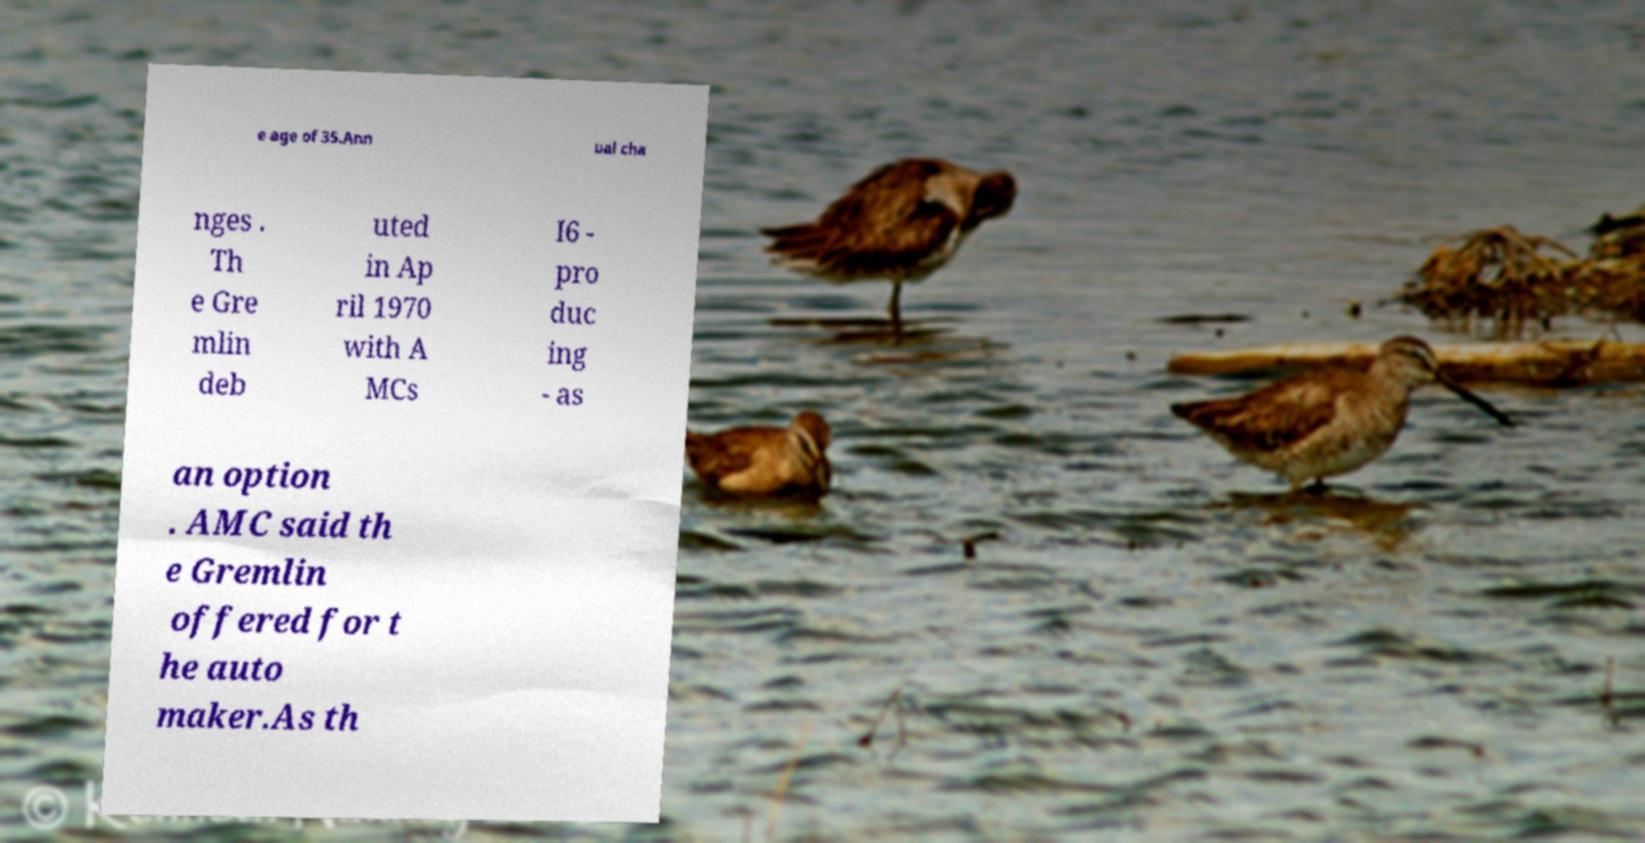Can you read and provide the text displayed in the image?This photo seems to have some interesting text. Can you extract and type it out for me? e age of 35.Ann ual cha nges . Th e Gre mlin deb uted in Ap ril 1970 with A MCs I6 - pro duc ing - as an option . AMC said th e Gremlin offered for t he auto maker.As th 